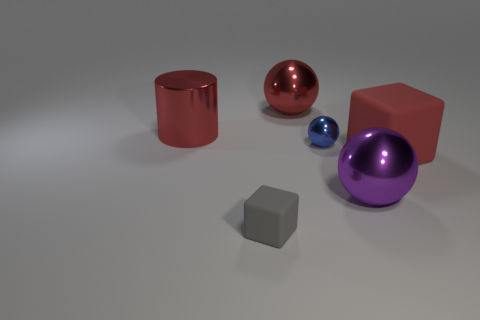Subtract 1 balls. How many balls are left? 2 Add 4 cyan blocks. How many objects exist? 10 Subtract all cylinders. How many objects are left? 5 Subtract 1 purple spheres. How many objects are left? 5 Subtract all yellow shiny things. Subtract all large red shiny cylinders. How many objects are left? 5 Add 1 big red metal objects. How many big red metal objects are left? 3 Add 3 red things. How many red things exist? 6 